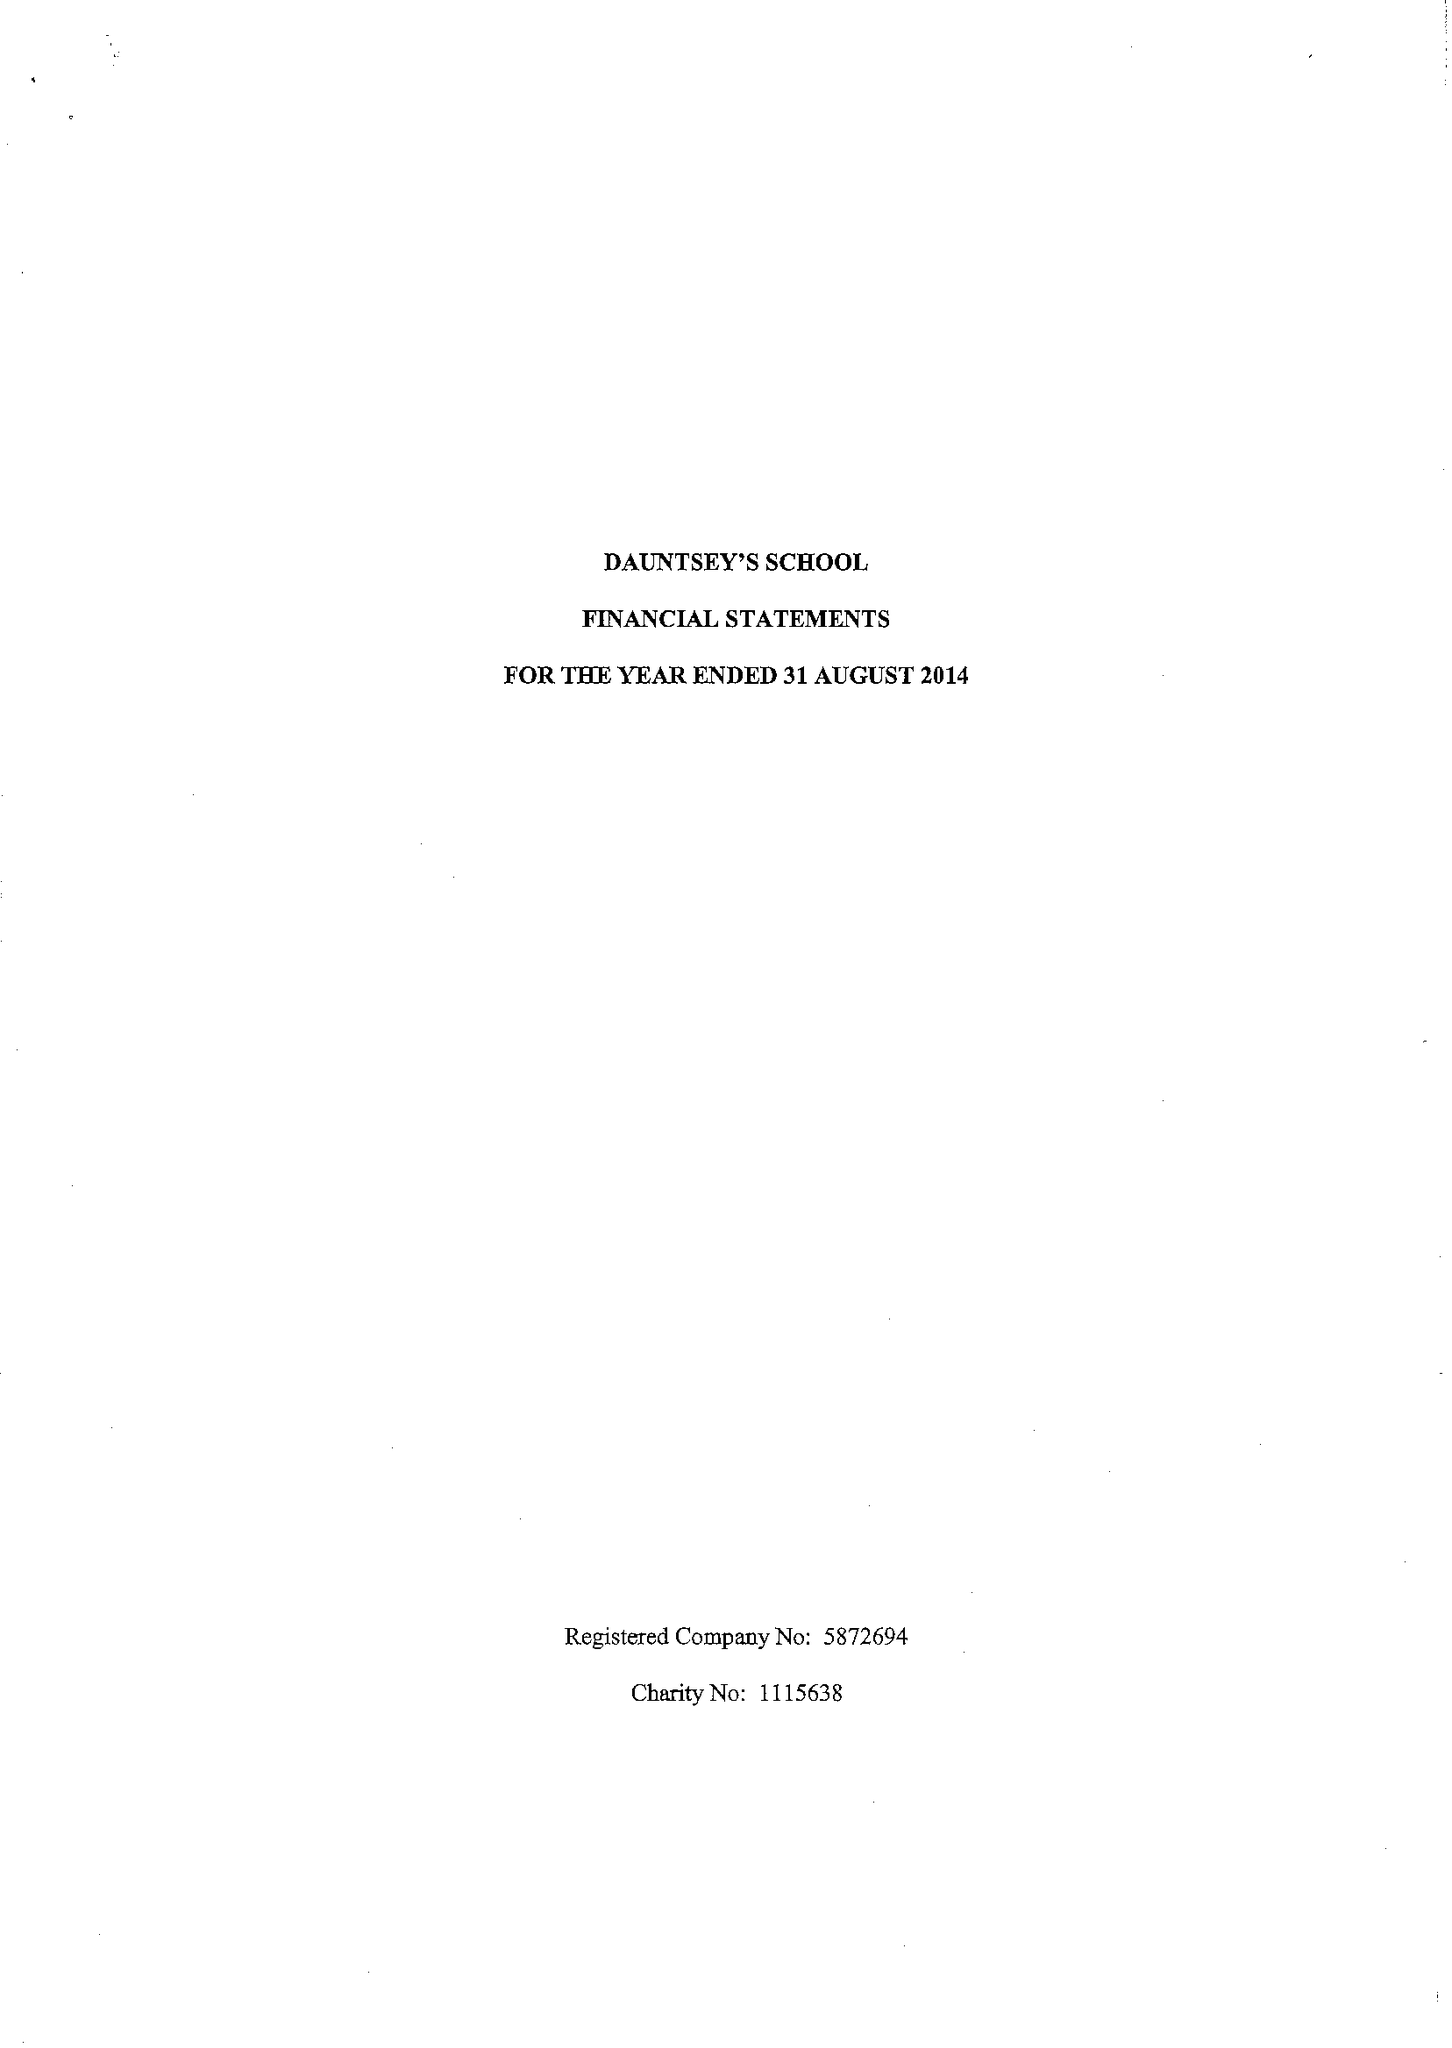What is the value for the charity_name?
Answer the question using a single word or phrase. Dauntsey's School 